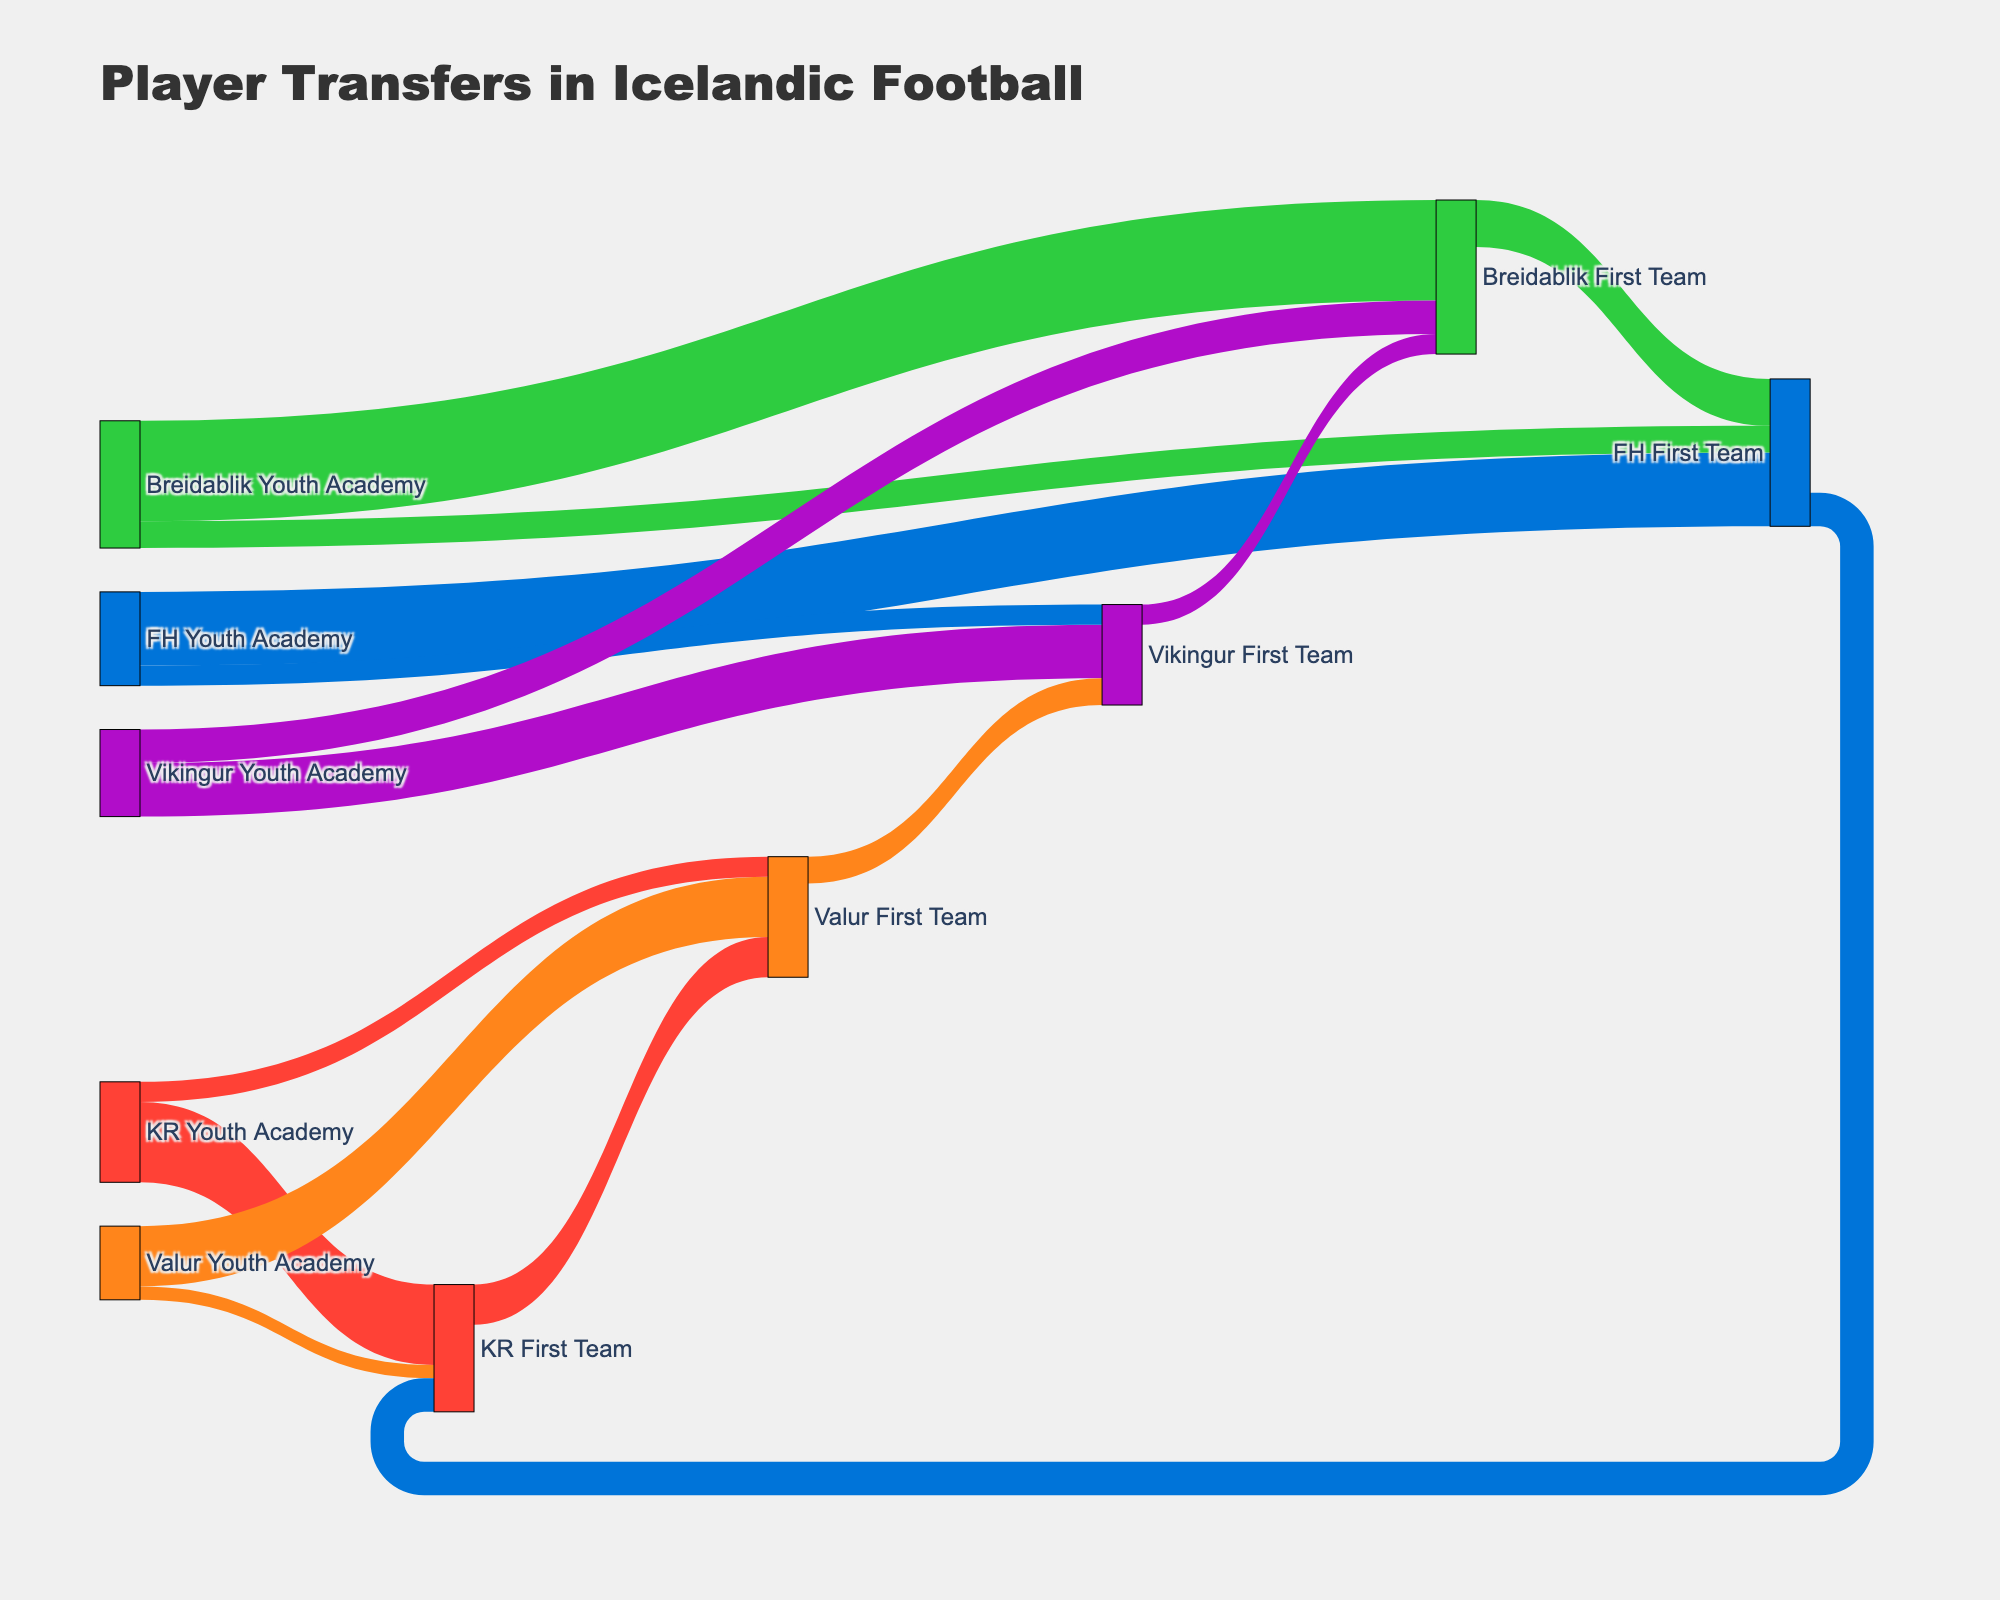What is the title of the Sankey diagram? The title of the diagram is typically displayed at the top. Here it is clearly mentioned.
Answer: Player Transfers in Icelandic Football Which youth academy has transferred the most players to its first team? By examining the values associated with the transfers from youth academies to their corresponding first teams, you can identify the highest value. Breidablik Youth Academy to Breidablik First Team has the largest value (15).
Answer: Breidablik Youth Academy How many players in total have moved from youth academies to their respective first teams? Sum of values for moves from all youth academies to their first teams: KR (12), Valur (9), Breidablik (15), FH (11), Vikingur (8). Summing these gives 12 + 9 + 15 + 11 + 8 = 55.
Answer: 55 Which teams have received players from the KR Youth Academy apart from KR First Team? Look at the links starting from KR Youth Academy leading to teams other than KR First Team. KR Youth Academy has sent players to Valur First Team (3).
Answer: Valur First Team Which team has transferred the most youth players away from their first team to other first teams? To find this, check each team’s outgoing transfers that involve other first teams. KR First Team has the highest value of 6 to Valur First Team.
Answer: KR First Team What is the sum of players transferred from Valur's entities (both youth academy and first team) to any other team? Sum values from Valur Youth Academy to other teams (2 KR First Team) and Valur First Team (Valur to Vikingur, 4). Total is 2 + 4 = 6.
Answer: 6 Which two first teams have exchanged players and what is the total of such exchanges? Identify teams that have sent and received players alternatively. KR First Team sent 6 to Valur First Team, and FH First Team sent 5 to KR First Team.
Answer: KR and Valur; Total 6 Is there any youth academy that has sent players not only to their first team but also to other teams’ first teams, and if so, which one has sent the most such players? Look at youth academies showing multiple outgoing links to various first teams, not just their own. KR Youth Academy sent 3 to Valur First Team, and Breidablik Youth Academy sent 4 to FH First Team, higher among them.
Answer: Breidablik Youth Academy 